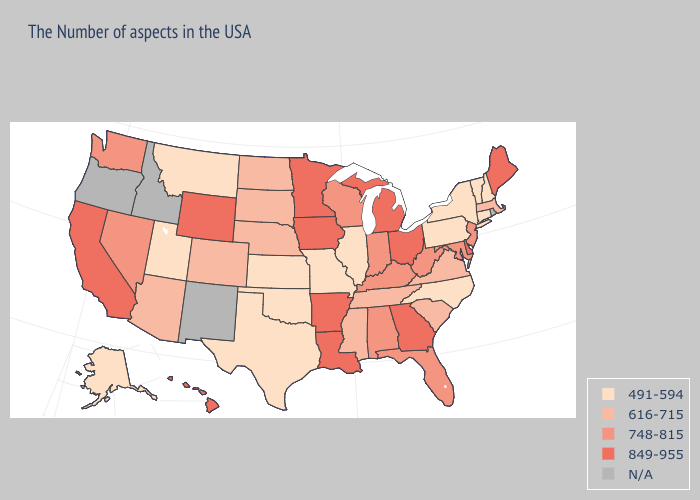What is the lowest value in states that border Nevada?
Keep it brief. 491-594. What is the value of Illinois?
Give a very brief answer. 491-594. Does South Dakota have the highest value in the MidWest?
Be succinct. No. What is the lowest value in the USA?
Write a very short answer. 491-594. Name the states that have a value in the range 491-594?
Give a very brief answer. New Hampshire, Vermont, Connecticut, New York, Pennsylvania, North Carolina, Illinois, Missouri, Kansas, Oklahoma, Texas, Utah, Montana, Alaska. Name the states that have a value in the range 616-715?
Short answer required. Massachusetts, Virginia, South Carolina, Tennessee, Mississippi, Nebraska, South Dakota, North Dakota, Colorado, Arizona. Among the states that border Nevada , which have the lowest value?
Answer briefly. Utah. Name the states that have a value in the range 849-955?
Write a very short answer. Maine, Delaware, Ohio, Georgia, Michigan, Louisiana, Arkansas, Minnesota, Iowa, Wyoming, California, Hawaii. What is the value of California?
Give a very brief answer. 849-955. What is the value of New Hampshire?
Write a very short answer. 491-594. Among the states that border Kansas , which have the lowest value?
Concise answer only. Missouri, Oklahoma. What is the value of Alabama?
Answer briefly. 748-815. What is the value of Delaware?
Concise answer only. 849-955. Name the states that have a value in the range 491-594?
Concise answer only. New Hampshire, Vermont, Connecticut, New York, Pennsylvania, North Carolina, Illinois, Missouri, Kansas, Oklahoma, Texas, Utah, Montana, Alaska. 